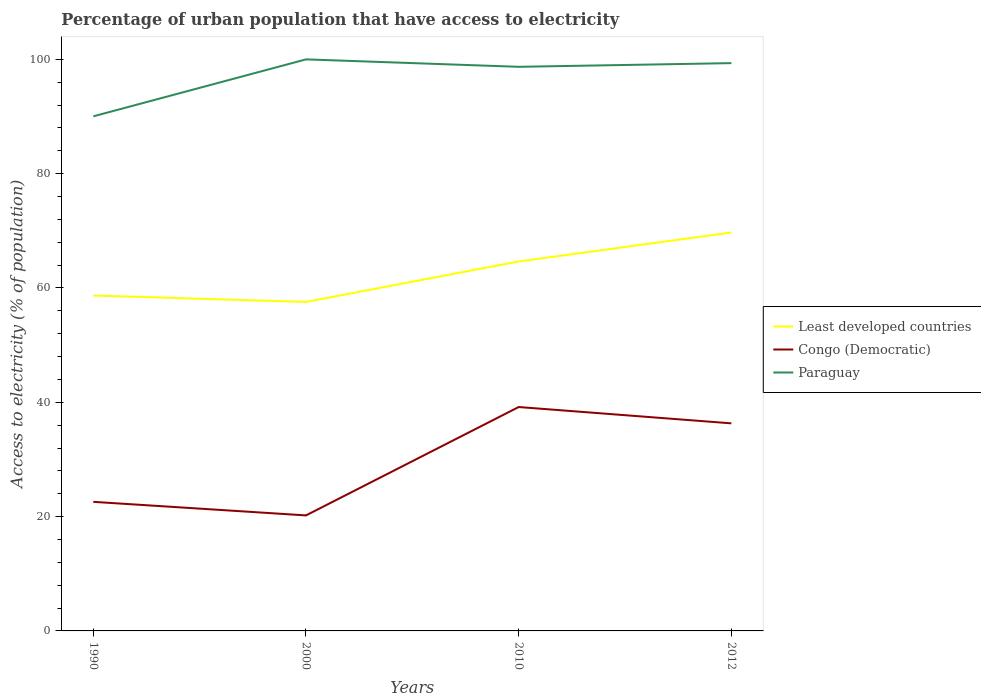Is the number of lines equal to the number of legend labels?
Provide a succinct answer. Yes. Across all years, what is the maximum percentage of urban population that have access to electricity in Congo (Democratic)?
Ensure brevity in your answer.  20.21. What is the total percentage of urban population that have access to electricity in Paraguay in the graph?
Offer a very short reply. -9.31. What is the difference between the highest and the second highest percentage of urban population that have access to electricity in Paraguay?
Your answer should be compact. 9.96. What is the difference between the highest and the lowest percentage of urban population that have access to electricity in Congo (Democratic)?
Your answer should be compact. 2. What is the difference between two consecutive major ticks on the Y-axis?
Provide a short and direct response. 20. Are the values on the major ticks of Y-axis written in scientific E-notation?
Give a very brief answer. No. Does the graph contain any zero values?
Your answer should be compact. No. Where does the legend appear in the graph?
Your answer should be compact. Center right. How many legend labels are there?
Your response must be concise. 3. What is the title of the graph?
Provide a succinct answer. Percentage of urban population that have access to electricity. What is the label or title of the Y-axis?
Your response must be concise. Access to electricity (% of population). What is the Access to electricity (% of population) in Least developed countries in 1990?
Provide a succinct answer. 58.68. What is the Access to electricity (% of population) in Congo (Democratic) in 1990?
Your response must be concise. 22.58. What is the Access to electricity (% of population) of Paraguay in 1990?
Offer a very short reply. 90.04. What is the Access to electricity (% of population) in Least developed countries in 2000?
Provide a short and direct response. 57.56. What is the Access to electricity (% of population) in Congo (Democratic) in 2000?
Provide a succinct answer. 20.21. What is the Access to electricity (% of population) in Paraguay in 2000?
Ensure brevity in your answer.  100. What is the Access to electricity (% of population) of Least developed countries in 2010?
Keep it short and to the point. 64.64. What is the Access to electricity (% of population) of Congo (Democratic) in 2010?
Keep it short and to the point. 39.17. What is the Access to electricity (% of population) of Paraguay in 2010?
Offer a terse response. 98.7. What is the Access to electricity (% of population) of Least developed countries in 2012?
Keep it short and to the point. 69.71. What is the Access to electricity (% of population) of Congo (Democratic) in 2012?
Make the answer very short. 36.32. What is the Access to electricity (% of population) in Paraguay in 2012?
Make the answer very short. 99.34. Across all years, what is the maximum Access to electricity (% of population) in Least developed countries?
Offer a terse response. 69.71. Across all years, what is the maximum Access to electricity (% of population) in Congo (Democratic)?
Your answer should be compact. 39.17. Across all years, what is the minimum Access to electricity (% of population) of Least developed countries?
Offer a very short reply. 57.56. Across all years, what is the minimum Access to electricity (% of population) in Congo (Democratic)?
Make the answer very short. 20.21. Across all years, what is the minimum Access to electricity (% of population) of Paraguay?
Your response must be concise. 90.04. What is the total Access to electricity (% of population) of Least developed countries in the graph?
Your response must be concise. 250.59. What is the total Access to electricity (% of population) in Congo (Democratic) in the graph?
Provide a short and direct response. 118.29. What is the total Access to electricity (% of population) of Paraguay in the graph?
Your response must be concise. 388.08. What is the difference between the Access to electricity (% of population) in Least developed countries in 1990 and that in 2000?
Offer a very short reply. 1.12. What is the difference between the Access to electricity (% of population) in Congo (Democratic) in 1990 and that in 2000?
Your answer should be compact. 2.37. What is the difference between the Access to electricity (% of population) in Paraguay in 1990 and that in 2000?
Make the answer very short. -9.96. What is the difference between the Access to electricity (% of population) in Least developed countries in 1990 and that in 2010?
Provide a short and direct response. -5.96. What is the difference between the Access to electricity (% of population) of Congo (Democratic) in 1990 and that in 2010?
Your answer should be compact. -16.59. What is the difference between the Access to electricity (% of population) in Paraguay in 1990 and that in 2010?
Provide a succinct answer. -8.66. What is the difference between the Access to electricity (% of population) of Least developed countries in 1990 and that in 2012?
Ensure brevity in your answer.  -11.03. What is the difference between the Access to electricity (% of population) in Congo (Democratic) in 1990 and that in 2012?
Give a very brief answer. -13.73. What is the difference between the Access to electricity (% of population) of Paraguay in 1990 and that in 2012?
Your answer should be very brief. -9.31. What is the difference between the Access to electricity (% of population) in Least developed countries in 2000 and that in 2010?
Offer a terse response. -7.08. What is the difference between the Access to electricity (% of population) in Congo (Democratic) in 2000 and that in 2010?
Provide a short and direct response. -18.96. What is the difference between the Access to electricity (% of population) in Paraguay in 2000 and that in 2010?
Keep it short and to the point. 1.3. What is the difference between the Access to electricity (% of population) in Least developed countries in 2000 and that in 2012?
Give a very brief answer. -12.15. What is the difference between the Access to electricity (% of population) of Congo (Democratic) in 2000 and that in 2012?
Make the answer very short. -16.11. What is the difference between the Access to electricity (% of population) of Paraguay in 2000 and that in 2012?
Give a very brief answer. 0.66. What is the difference between the Access to electricity (% of population) in Least developed countries in 2010 and that in 2012?
Keep it short and to the point. -5.07. What is the difference between the Access to electricity (% of population) in Congo (Democratic) in 2010 and that in 2012?
Make the answer very short. 2.86. What is the difference between the Access to electricity (% of population) of Paraguay in 2010 and that in 2012?
Offer a very short reply. -0.64. What is the difference between the Access to electricity (% of population) of Least developed countries in 1990 and the Access to electricity (% of population) of Congo (Democratic) in 2000?
Provide a succinct answer. 38.47. What is the difference between the Access to electricity (% of population) of Least developed countries in 1990 and the Access to electricity (% of population) of Paraguay in 2000?
Make the answer very short. -41.32. What is the difference between the Access to electricity (% of population) in Congo (Democratic) in 1990 and the Access to electricity (% of population) in Paraguay in 2000?
Keep it short and to the point. -77.42. What is the difference between the Access to electricity (% of population) in Least developed countries in 1990 and the Access to electricity (% of population) in Congo (Democratic) in 2010?
Provide a short and direct response. 19.51. What is the difference between the Access to electricity (% of population) in Least developed countries in 1990 and the Access to electricity (% of population) in Paraguay in 2010?
Your response must be concise. -40.02. What is the difference between the Access to electricity (% of population) in Congo (Democratic) in 1990 and the Access to electricity (% of population) in Paraguay in 2010?
Provide a succinct answer. -76.12. What is the difference between the Access to electricity (% of population) of Least developed countries in 1990 and the Access to electricity (% of population) of Congo (Democratic) in 2012?
Your answer should be compact. 22.36. What is the difference between the Access to electricity (% of population) of Least developed countries in 1990 and the Access to electricity (% of population) of Paraguay in 2012?
Offer a terse response. -40.66. What is the difference between the Access to electricity (% of population) of Congo (Democratic) in 1990 and the Access to electricity (% of population) of Paraguay in 2012?
Your answer should be very brief. -76.76. What is the difference between the Access to electricity (% of population) in Least developed countries in 2000 and the Access to electricity (% of population) in Congo (Democratic) in 2010?
Ensure brevity in your answer.  18.39. What is the difference between the Access to electricity (% of population) in Least developed countries in 2000 and the Access to electricity (% of population) in Paraguay in 2010?
Offer a very short reply. -41.14. What is the difference between the Access to electricity (% of population) of Congo (Democratic) in 2000 and the Access to electricity (% of population) of Paraguay in 2010?
Offer a terse response. -78.49. What is the difference between the Access to electricity (% of population) in Least developed countries in 2000 and the Access to electricity (% of population) in Congo (Democratic) in 2012?
Your answer should be compact. 21.24. What is the difference between the Access to electricity (% of population) of Least developed countries in 2000 and the Access to electricity (% of population) of Paraguay in 2012?
Your answer should be very brief. -41.78. What is the difference between the Access to electricity (% of population) in Congo (Democratic) in 2000 and the Access to electricity (% of population) in Paraguay in 2012?
Offer a very short reply. -79.13. What is the difference between the Access to electricity (% of population) in Least developed countries in 2010 and the Access to electricity (% of population) in Congo (Democratic) in 2012?
Provide a succinct answer. 28.32. What is the difference between the Access to electricity (% of population) of Least developed countries in 2010 and the Access to electricity (% of population) of Paraguay in 2012?
Ensure brevity in your answer.  -34.7. What is the difference between the Access to electricity (% of population) of Congo (Democratic) in 2010 and the Access to electricity (% of population) of Paraguay in 2012?
Make the answer very short. -60.17. What is the average Access to electricity (% of population) of Least developed countries per year?
Give a very brief answer. 62.65. What is the average Access to electricity (% of population) of Congo (Democratic) per year?
Provide a succinct answer. 29.57. What is the average Access to electricity (% of population) in Paraguay per year?
Provide a succinct answer. 97.02. In the year 1990, what is the difference between the Access to electricity (% of population) in Least developed countries and Access to electricity (% of population) in Congo (Democratic)?
Provide a succinct answer. 36.1. In the year 1990, what is the difference between the Access to electricity (% of population) of Least developed countries and Access to electricity (% of population) of Paraguay?
Your answer should be compact. -31.35. In the year 1990, what is the difference between the Access to electricity (% of population) of Congo (Democratic) and Access to electricity (% of population) of Paraguay?
Ensure brevity in your answer.  -67.45. In the year 2000, what is the difference between the Access to electricity (% of population) in Least developed countries and Access to electricity (% of population) in Congo (Democratic)?
Make the answer very short. 37.35. In the year 2000, what is the difference between the Access to electricity (% of population) of Least developed countries and Access to electricity (% of population) of Paraguay?
Your answer should be compact. -42.44. In the year 2000, what is the difference between the Access to electricity (% of population) in Congo (Democratic) and Access to electricity (% of population) in Paraguay?
Your answer should be very brief. -79.79. In the year 2010, what is the difference between the Access to electricity (% of population) of Least developed countries and Access to electricity (% of population) of Congo (Democratic)?
Your answer should be very brief. 25.47. In the year 2010, what is the difference between the Access to electricity (% of population) of Least developed countries and Access to electricity (% of population) of Paraguay?
Your response must be concise. -34.06. In the year 2010, what is the difference between the Access to electricity (% of population) of Congo (Democratic) and Access to electricity (% of population) of Paraguay?
Make the answer very short. -59.53. In the year 2012, what is the difference between the Access to electricity (% of population) in Least developed countries and Access to electricity (% of population) in Congo (Democratic)?
Your answer should be very brief. 33.39. In the year 2012, what is the difference between the Access to electricity (% of population) of Least developed countries and Access to electricity (% of population) of Paraguay?
Your answer should be compact. -29.63. In the year 2012, what is the difference between the Access to electricity (% of population) of Congo (Democratic) and Access to electricity (% of population) of Paraguay?
Provide a short and direct response. -63.03. What is the ratio of the Access to electricity (% of population) of Least developed countries in 1990 to that in 2000?
Offer a terse response. 1.02. What is the ratio of the Access to electricity (% of population) of Congo (Democratic) in 1990 to that in 2000?
Offer a terse response. 1.12. What is the ratio of the Access to electricity (% of population) of Paraguay in 1990 to that in 2000?
Your answer should be compact. 0.9. What is the ratio of the Access to electricity (% of population) in Least developed countries in 1990 to that in 2010?
Provide a short and direct response. 0.91. What is the ratio of the Access to electricity (% of population) of Congo (Democratic) in 1990 to that in 2010?
Your answer should be compact. 0.58. What is the ratio of the Access to electricity (% of population) of Paraguay in 1990 to that in 2010?
Your response must be concise. 0.91. What is the ratio of the Access to electricity (% of population) of Least developed countries in 1990 to that in 2012?
Your answer should be very brief. 0.84. What is the ratio of the Access to electricity (% of population) of Congo (Democratic) in 1990 to that in 2012?
Provide a short and direct response. 0.62. What is the ratio of the Access to electricity (% of population) in Paraguay in 1990 to that in 2012?
Offer a terse response. 0.91. What is the ratio of the Access to electricity (% of population) in Least developed countries in 2000 to that in 2010?
Offer a terse response. 0.89. What is the ratio of the Access to electricity (% of population) of Congo (Democratic) in 2000 to that in 2010?
Give a very brief answer. 0.52. What is the ratio of the Access to electricity (% of population) of Paraguay in 2000 to that in 2010?
Offer a very short reply. 1.01. What is the ratio of the Access to electricity (% of population) of Least developed countries in 2000 to that in 2012?
Ensure brevity in your answer.  0.83. What is the ratio of the Access to electricity (% of population) of Congo (Democratic) in 2000 to that in 2012?
Your response must be concise. 0.56. What is the ratio of the Access to electricity (% of population) in Paraguay in 2000 to that in 2012?
Your response must be concise. 1.01. What is the ratio of the Access to electricity (% of population) in Least developed countries in 2010 to that in 2012?
Provide a short and direct response. 0.93. What is the ratio of the Access to electricity (% of population) in Congo (Democratic) in 2010 to that in 2012?
Ensure brevity in your answer.  1.08. What is the ratio of the Access to electricity (% of population) of Paraguay in 2010 to that in 2012?
Ensure brevity in your answer.  0.99. What is the difference between the highest and the second highest Access to electricity (% of population) of Least developed countries?
Your answer should be compact. 5.07. What is the difference between the highest and the second highest Access to electricity (% of population) in Congo (Democratic)?
Your response must be concise. 2.86. What is the difference between the highest and the second highest Access to electricity (% of population) in Paraguay?
Provide a succinct answer. 0.66. What is the difference between the highest and the lowest Access to electricity (% of population) of Least developed countries?
Offer a terse response. 12.15. What is the difference between the highest and the lowest Access to electricity (% of population) of Congo (Democratic)?
Keep it short and to the point. 18.96. What is the difference between the highest and the lowest Access to electricity (% of population) in Paraguay?
Keep it short and to the point. 9.96. 